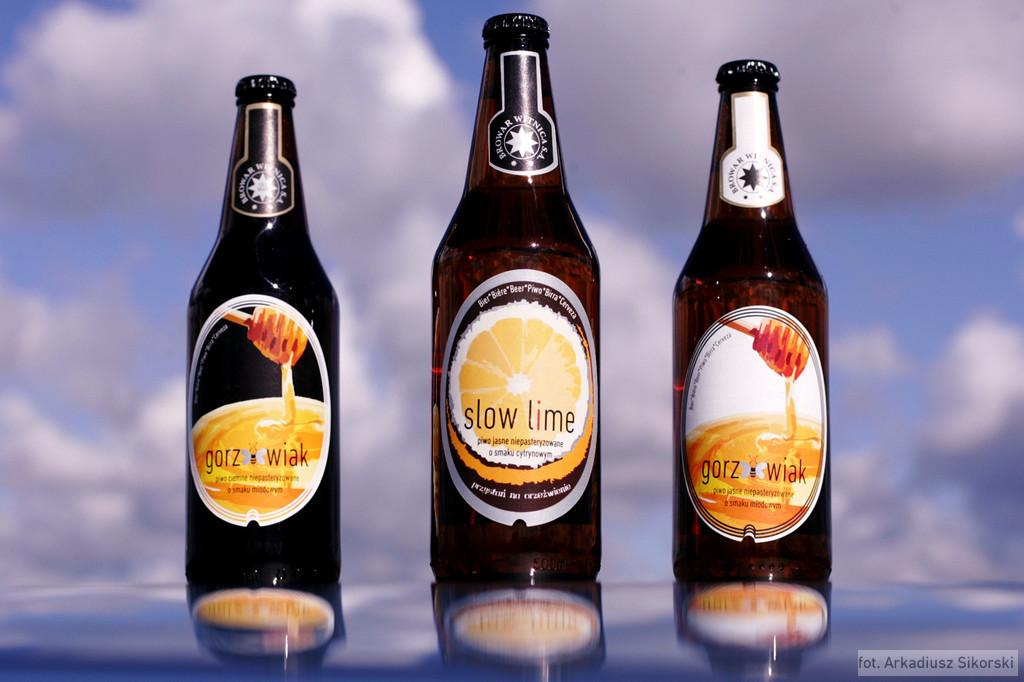How many bottles are visible in the image? There are three bottles in the image. What color are the toes of the person in the image? There is no person present in the image, only three bottles. What type of sheet is covering the bottles in the image? There is no sheet covering the bottles in the image; they are visible and not obstructed. 